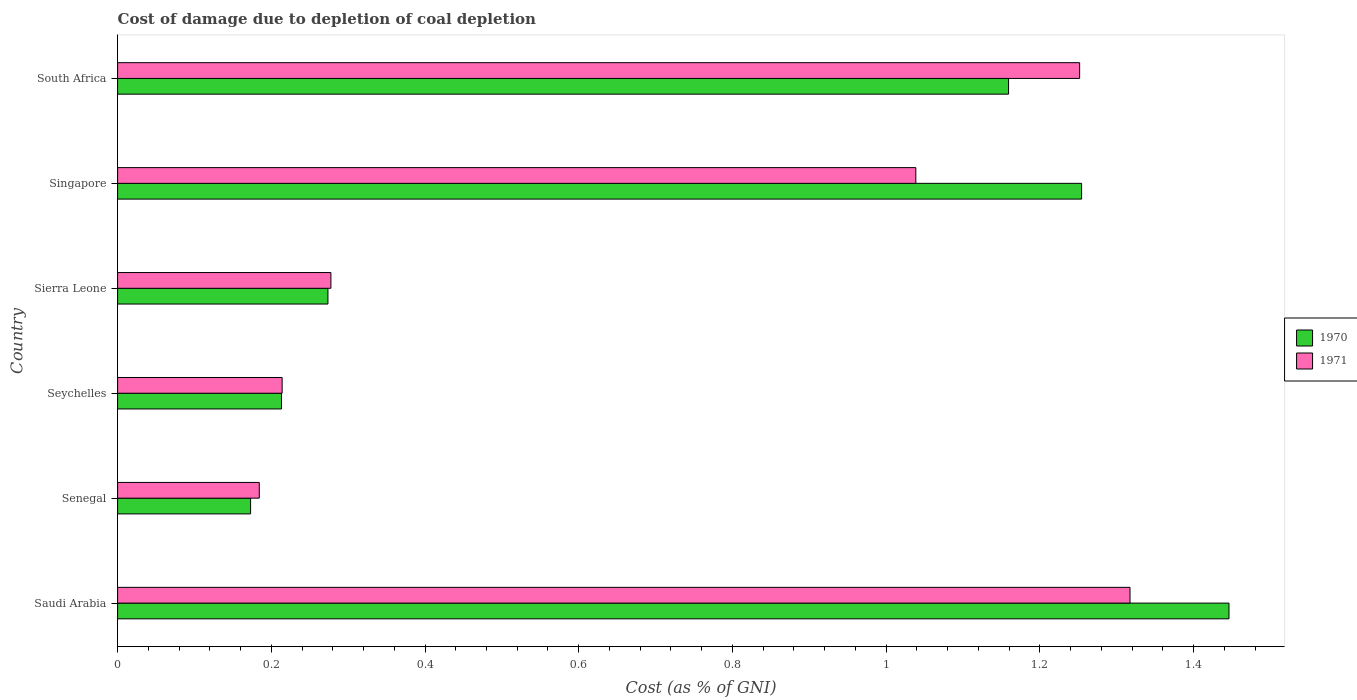How many groups of bars are there?
Provide a succinct answer. 6. What is the label of the 6th group of bars from the top?
Your response must be concise. Saudi Arabia. What is the cost of damage caused due to coal depletion in 1970 in Senegal?
Provide a succinct answer. 0.17. Across all countries, what is the maximum cost of damage caused due to coal depletion in 1971?
Your answer should be very brief. 1.32. Across all countries, what is the minimum cost of damage caused due to coal depletion in 1970?
Provide a short and direct response. 0.17. In which country was the cost of damage caused due to coal depletion in 1970 maximum?
Provide a succinct answer. Saudi Arabia. In which country was the cost of damage caused due to coal depletion in 1970 minimum?
Your answer should be very brief. Senegal. What is the total cost of damage caused due to coal depletion in 1971 in the graph?
Offer a terse response. 4.28. What is the difference between the cost of damage caused due to coal depletion in 1971 in Seychelles and that in South Africa?
Provide a succinct answer. -1.04. What is the difference between the cost of damage caused due to coal depletion in 1970 in Singapore and the cost of damage caused due to coal depletion in 1971 in Sierra Leone?
Offer a terse response. 0.98. What is the average cost of damage caused due to coal depletion in 1970 per country?
Offer a terse response. 0.75. What is the difference between the cost of damage caused due to coal depletion in 1971 and cost of damage caused due to coal depletion in 1970 in Senegal?
Ensure brevity in your answer.  0.01. In how many countries, is the cost of damage caused due to coal depletion in 1971 greater than 0.9600000000000001 %?
Your response must be concise. 3. What is the ratio of the cost of damage caused due to coal depletion in 1971 in Saudi Arabia to that in Sierra Leone?
Provide a succinct answer. 4.75. Is the difference between the cost of damage caused due to coal depletion in 1971 in Saudi Arabia and Seychelles greater than the difference between the cost of damage caused due to coal depletion in 1970 in Saudi Arabia and Seychelles?
Make the answer very short. No. What is the difference between the highest and the second highest cost of damage caused due to coal depletion in 1971?
Offer a terse response. 0.07. What is the difference between the highest and the lowest cost of damage caused due to coal depletion in 1970?
Offer a terse response. 1.27. In how many countries, is the cost of damage caused due to coal depletion in 1970 greater than the average cost of damage caused due to coal depletion in 1970 taken over all countries?
Provide a short and direct response. 3. What does the 1st bar from the top in Sierra Leone represents?
Offer a terse response. 1971. What does the 1st bar from the bottom in Sierra Leone represents?
Your response must be concise. 1970. How many bars are there?
Give a very brief answer. 12. Are all the bars in the graph horizontal?
Ensure brevity in your answer.  Yes. What is the difference between two consecutive major ticks on the X-axis?
Give a very brief answer. 0.2. Are the values on the major ticks of X-axis written in scientific E-notation?
Ensure brevity in your answer.  No. Does the graph contain any zero values?
Give a very brief answer. No. Does the graph contain grids?
Provide a short and direct response. No. What is the title of the graph?
Your response must be concise. Cost of damage due to depletion of coal depletion. What is the label or title of the X-axis?
Your answer should be very brief. Cost (as % of GNI). What is the Cost (as % of GNI) of 1970 in Saudi Arabia?
Keep it short and to the point. 1.45. What is the Cost (as % of GNI) in 1971 in Saudi Arabia?
Keep it short and to the point. 1.32. What is the Cost (as % of GNI) of 1970 in Senegal?
Your answer should be compact. 0.17. What is the Cost (as % of GNI) in 1971 in Senegal?
Make the answer very short. 0.18. What is the Cost (as % of GNI) of 1970 in Seychelles?
Provide a succinct answer. 0.21. What is the Cost (as % of GNI) of 1971 in Seychelles?
Make the answer very short. 0.21. What is the Cost (as % of GNI) in 1970 in Sierra Leone?
Provide a short and direct response. 0.27. What is the Cost (as % of GNI) in 1971 in Sierra Leone?
Keep it short and to the point. 0.28. What is the Cost (as % of GNI) of 1970 in Singapore?
Offer a terse response. 1.25. What is the Cost (as % of GNI) of 1971 in Singapore?
Provide a short and direct response. 1.04. What is the Cost (as % of GNI) in 1970 in South Africa?
Your answer should be very brief. 1.16. What is the Cost (as % of GNI) of 1971 in South Africa?
Give a very brief answer. 1.25. Across all countries, what is the maximum Cost (as % of GNI) of 1970?
Offer a very short reply. 1.45. Across all countries, what is the maximum Cost (as % of GNI) of 1971?
Offer a very short reply. 1.32. Across all countries, what is the minimum Cost (as % of GNI) of 1970?
Offer a very short reply. 0.17. Across all countries, what is the minimum Cost (as % of GNI) of 1971?
Make the answer very short. 0.18. What is the total Cost (as % of GNI) in 1970 in the graph?
Ensure brevity in your answer.  4.52. What is the total Cost (as % of GNI) of 1971 in the graph?
Make the answer very short. 4.28. What is the difference between the Cost (as % of GNI) of 1970 in Saudi Arabia and that in Senegal?
Offer a terse response. 1.27. What is the difference between the Cost (as % of GNI) of 1971 in Saudi Arabia and that in Senegal?
Your answer should be very brief. 1.13. What is the difference between the Cost (as % of GNI) in 1970 in Saudi Arabia and that in Seychelles?
Provide a succinct answer. 1.23. What is the difference between the Cost (as % of GNI) of 1971 in Saudi Arabia and that in Seychelles?
Give a very brief answer. 1.1. What is the difference between the Cost (as % of GNI) of 1970 in Saudi Arabia and that in Sierra Leone?
Make the answer very short. 1.17. What is the difference between the Cost (as % of GNI) of 1971 in Saudi Arabia and that in Sierra Leone?
Make the answer very short. 1.04. What is the difference between the Cost (as % of GNI) in 1970 in Saudi Arabia and that in Singapore?
Your answer should be very brief. 0.19. What is the difference between the Cost (as % of GNI) of 1971 in Saudi Arabia and that in Singapore?
Provide a succinct answer. 0.28. What is the difference between the Cost (as % of GNI) of 1970 in Saudi Arabia and that in South Africa?
Ensure brevity in your answer.  0.29. What is the difference between the Cost (as % of GNI) of 1971 in Saudi Arabia and that in South Africa?
Provide a succinct answer. 0.07. What is the difference between the Cost (as % of GNI) in 1970 in Senegal and that in Seychelles?
Your answer should be very brief. -0.04. What is the difference between the Cost (as % of GNI) in 1971 in Senegal and that in Seychelles?
Your answer should be compact. -0.03. What is the difference between the Cost (as % of GNI) in 1970 in Senegal and that in Sierra Leone?
Your answer should be very brief. -0.1. What is the difference between the Cost (as % of GNI) in 1971 in Senegal and that in Sierra Leone?
Your answer should be very brief. -0.09. What is the difference between the Cost (as % of GNI) of 1970 in Senegal and that in Singapore?
Offer a very short reply. -1.08. What is the difference between the Cost (as % of GNI) in 1971 in Senegal and that in Singapore?
Provide a short and direct response. -0.85. What is the difference between the Cost (as % of GNI) in 1970 in Senegal and that in South Africa?
Ensure brevity in your answer.  -0.99. What is the difference between the Cost (as % of GNI) of 1971 in Senegal and that in South Africa?
Offer a terse response. -1.07. What is the difference between the Cost (as % of GNI) of 1970 in Seychelles and that in Sierra Leone?
Offer a very short reply. -0.06. What is the difference between the Cost (as % of GNI) in 1971 in Seychelles and that in Sierra Leone?
Your answer should be very brief. -0.06. What is the difference between the Cost (as % of GNI) in 1970 in Seychelles and that in Singapore?
Keep it short and to the point. -1.04. What is the difference between the Cost (as % of GNI) of 1971 in Seychelles and that in Singapore?
Provide a succinct answer. -0.82. What is the difference between the Cost (as % of GNI) in 1970 in Seychelles and that in South Africa?
Offer a terse response. -0.95. What is the difference between the Cost (as % of GNI) of 1971 in Seychelles and that in South Africa?
Make the answer very short. -1.04. What is the difference between the Cost (as % of GNI) in 1970 in Sierra Leone and that in Singapore?
Your answer should be compact. -0.98. What is the difference between the Cost (as % of GNI) of 1971 in Sierra Leone and that in Singapore?
Your answer should be compact. -0.76. What is the difference between the Cost (as % of GNI) in 1970 in Sierra Leone and that in South Africa?
Make the answer very short. -0.89. What is the difference between the Cost (as % of GNI) in 1971 in Sierra Leone and that in South Africa?
Ensure brevity in your answer.  -0.97. What is the difference between the Cost (as % of GNI) of 1970 in Singapore and that in South Africa?
Provide a short and direct response. 0.1. What is the difference between the Cost (as % of GNI) of 1971 in Singapore and that in South Africa?
Your answer should be very brief. -0.21. What is the difference between the Cost (as % of GNI) of 1970 in Saudi Arabia and the Cost (as % of GNI) of 1971 in Senegal?
Provide a succinct answer. 1.26. What is the difference between the Cost (as % of GNI) of 1970 in Saudi Arabia and the Cost (as % of GNI) of 1971 in Seychelles?
Your answer should be compact. 1.23. What is the difference between the Cost (as % of GNI) in 1970 in Saudi Arabia and the Cost (as % of GNI) in 1971 in Sierra Leone?
Provide a succinct answer. 1.17. What is the difference between the Cost (as % of GNI) in 1970 in Saudi Arabia and the Cost (as % of GNI) in 1971 in Singapore?
Your answer should be compact. 0.41. What is the difference between the Cost (as % of GNI) of 1970 in Saudi Arabia and the Cost (as % of GNI) of 1971 in South Africa?
Make the answer very short. 0.19. What is the difference between the Cost (as % of GNI) in 1970 in Senegal and the Cost (as % of GNI) in 1971 in Seychelles?
Your answer should be compact. -0.04. What is the difference between the Cost (as % of GNI) in 1970 in Senegal and the Cost (as % of GNI) in 1971 in Sierra Leone?
Provide a short and direct response. -0.1. What is the difference between the Cost (as % of GNI) in 1970 in Senegal and the Cost (as % of GNI) in 1971 in Singapore?
Keep it short and to the point. -0.87. What is the difference between the Cost (as % of GNI) in 1970 in Senegal and the Cost (as % of GNI) in 1971 in South Africa?
Offer a terse response. -1.08. What is the difference between the Cost (as % of GNI) in 1970 in Seychelles and the Cost (as % of GNI) in 1971 in Sierra Leone?
Keep it short and to the point. -0.06. What is the difference between the Cost (as % of GNI) in 1970 in Seychelles and the Cost (as % of GNI) in 1971 in Singapore?
Provide a succinct answer. -0.83. What is the difference between the Cost (as % of GNI) of 1970 in Seychelles and the Cost (as % of GNI) of 1971 in South Africa?
Keep it short and to the point. -1.04. What is the difference between the Cost (as % of GNI) of 1970 in Sierra Leone and the Cost (as % of GNI) of 1971 in Singapore?
Ensure brevity in your answer.  -0.77. What is the difference between the Cost (as % of GNI) in 1970 in Sierra Leone and the Cost (as % of GNI) in 1971 in South Africa?
Make the answer very short. -0.98. What is the difference between the Cost (as % of GNI) of 1970 in Singapore and the Cost (as % of GNI) of 1971 in South Africa?
Provide a short and direct response. 0. What is the average Cost (as % of GNI) of 1970 per country?
Provide a succinct answer. 0.75. What is the average Cost (as % of GNI) of 1971 per country?
Offer a terse response. 0.71. What is the difference between the Cost (as % of GNI) in 1970 and Cost (as % of GNI) in 1971 in Saudi Arabia?
Provide a short and direct response. 0.13. What is the difference between the Cost (as % of GNI) of 1970 and Cost (as % of GNI) of 1971 in Senegal?
Offer a very short reply. -0.01. What is the difference between the Cost (as % of GNI) of 1970 and Cost (as % of GNI) of 1971 in Seychelles?
Make the answer very short. -0. What is the difference between the Cost (as % of GNI) of 1970 and Cost (as % of GNI) of 1971 in Sierra Leone?
Make the answer very short. -0. What is the difference between the Cost (as % of GNI) of 1970 and Cost (as % of GNI) of 1971 in Singapore?
Offer a terse response. 0.22. What is the difference between the Cost (as % of GNI) of 1970 and Cost (as % of GNI) of 1971 in South Africa?
Ensure brevity in your answer.  -0.09. What is the ratio of the Cost (as % of GNI) in 1970 in Saudi Arabia to that in Senegal?
Keep it short and to the point. 8.36. What is the ratio of the Cost (as % of GNI) of 1971 in Saudi Arabia to that in Senegal?
Offer a terse response. 7.15. What is the ratio of the Cost (as % of GNI) in 1970 in Saudi Arabia to that in Seychelles?
Ensure brevity in your answer.  6.78. What is the ratio of the Cost (as % of GNI) of 1971 in Saudi Arabia to that in Seychelles?
Offer a very short reply. 6.15. What is the ratio of the Cost (as % of GNI) in 1970 in Saudi Arabia to that in Sierra Leone?
Provide a succinct answer. 5.28. What is the ratio of the Cost (as % of GNI) in 1971 in Saudi Arabia to that in Sierra Leone?
Provide a succinct answer. 4.75. What is the ratio of the Cost (as % of GNI) of 1970 in Saudi Arabia to that in Singapore?
Your answer should be compact. 1.15. What is the ratio of the Cost (as % of GNI) of 1971 in Saudi Arabia to that in Singapore?
Provide a succinct answer. 1.27. What is the ratio of the Cost (as % of GNI) of 1970 in Saudi Arabia to that in South Africa?
Make the answer very short. 1.25. What is the ratio of the Cost (as % of GNI) of 1971 in Saudi Arabia to that in South Africa?
Make the answer very short. 1.05. What is the ratio of the Cost (as % of GNI) of 1970 in Senegal to that in Seychelles?
Keep it short and to the point. 0.81. What is the ratio of the Cost (as % of GNI) in 1971 in Senegal to that in Seychelles?
Provide a short and direct response. 0.86. What is the ratio of the Cost (as % of GNI) of 1970 in Senegal to that in Sierra Leone?
Offer a terse response. 0.63. What is the ratio of the Cost (as % of GNI) in 1971 in Senegal to that in Sierra Leone?
Give a very brief answer. 0.66. What is the ratio of the Cost (as % of GNI) of 1970 in Senegal to that in Singapore?
Your answer should be compact. 0.14. What is the ratio of the Cost (as % of GNI) of 1971 in Senegal to that in Singapore?
Offer a terse response. 0.18. What is the ratio of the Cost (as % of GNI) in 1970 in Senegal to that in South Africa?
Keep it short and to the point. 0.15. What is the ratio of the Cost (as % of GNI) of 1971 in Senegal to that in South Africa?
Your answer should be very brief. 0.15. What is the ratio of the Cost (as % of GNI) of 1970 in Seychelles to that in Sierra Leone?
Offer a terse response. 0.78. What is the ratio of the Cost (as % of GNI) of 1971 in Seychelles to that in Sierra Leone?
Give a very brief answer. 0.77. What is the ratio of the Cost (as % of GNI) of 1970 in Seychelles to that in Singapore?
Provide a short and direct response. 0.17. What is the ratio of the Cost (as % of GNI) of 1971 in Seychelles to that in Singapore?
Provide a short and direct response. 0.21. What is the ratio of the Cost (as % of GNI) in 1970 in Seychelles to that in South Africa?
Keep it short and to the point. 0.18. What is the ratio of the Cost (as % of GNI) of 1971 in Seychelles to that in South Africa?
Provide a short and direct response. 0.17. What is the ratio of the Cost (as % of GNI) of 1970 in Sierra Leone to that in Singapore?
Ensure brevity in your answer.  0.22. What is the ratio of the Cost (as % of GNI) of 1971 in Sierra Leone to that in Singapore?
Keep it short and to the point. 0.27. What is the ratio of the Cost (as % of GNI) in 1970 in Sierra Leone to that in South Africa?
Keep it short and to the point. 0.24. What is the ratio of the Cost (as % of GNI) in 1971 in Sierra Leone to that in South Africa?
Make the answer very short. 0.22. What is the ratio of the Cost (as % of GNI) of 1970 in Singapore to that in South Africa?
Provide a short and direct response. 1.08. What is the ratio of the Cost (as % of GNI) of 1971 in Singapore to that in South Africa?
Your answer should be compact. 0.83. What is the difference between the highest and the second highest Cost (as % of GNI) of 1970?
Your answer should be compact. 0.19. What is the difference between the highest and the second highest Cost (as % of GNI) in 1971?
Provide a short and direct response. 0.07. What is the difference between the highest and the lowest Cost (as % of GNI) in 1970?
Make the answer very short. 1.27. What is the difference between the highest and the lowest Cost (as % of GNI) of 1971?
Your response must be concise. 1.13. 